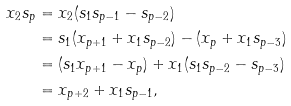Convert formula to latex. <formula><loc_0><loc_0><loc_500><loc_500>x _ { 2 } s _ { p } & = x _ { 2 } ( s _ { 1 } s _ { p - 1 } - s _ { p - 2 } ) \\ & = s _ { 1 } ( x _ { p + 1 } + x _ { 1 } s _ { p - 2 } ) - ( x _ { p } + x _ { 1 } s _ { p - 3 } ) \\ & = ( s _ { 1 } x _ { p + 1 } - x _ { p } ) + x _ { 1 } ( s _ { 1 } s _ { p - 2 } - s _ { p - 3 } ) \\ & = x _ { p + 2 } + x _ { 1 } s _ { p - 1 } ,</formula> 